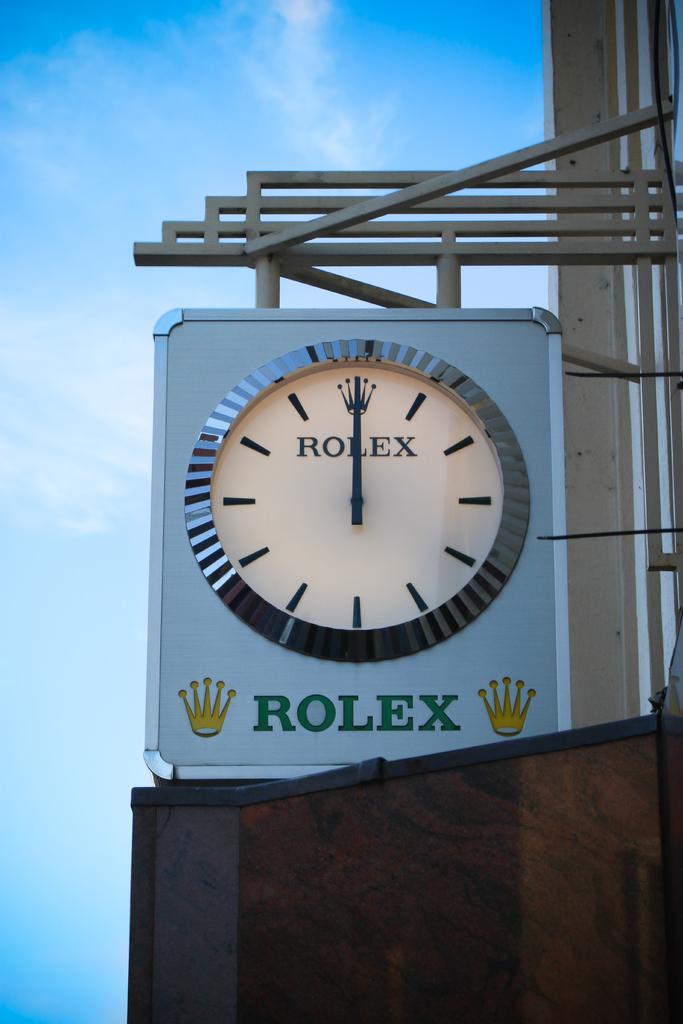What time is it?
Ensure brevity in your answer.  12:00. What brand is on the clock?
Offer a terse response. Rolex. 